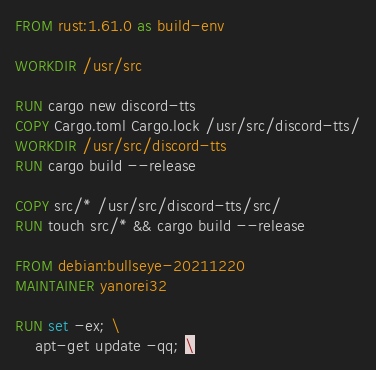Convert code to text. <code><loc_0><loc_0><loc_500><loc_500><_Dockerfile_>FROM rust:1.61.0 as build-env

WORKDIR /usr/src

RUN cargo new discord-tts
COPY Cargo.toml Cargo.lock /usr/src/discord-tts/
WORKDIR /usr/src/discord-tts
RUN cargo build --release

COPY src/* /usr/src/discord-tts/src/
RUN touch src/* && cargo build --release

FROM debian:bullseye-20211220
MAINTAINER yanorei32

RUN set -ex; \
	apt-get update -qq; \</code> 